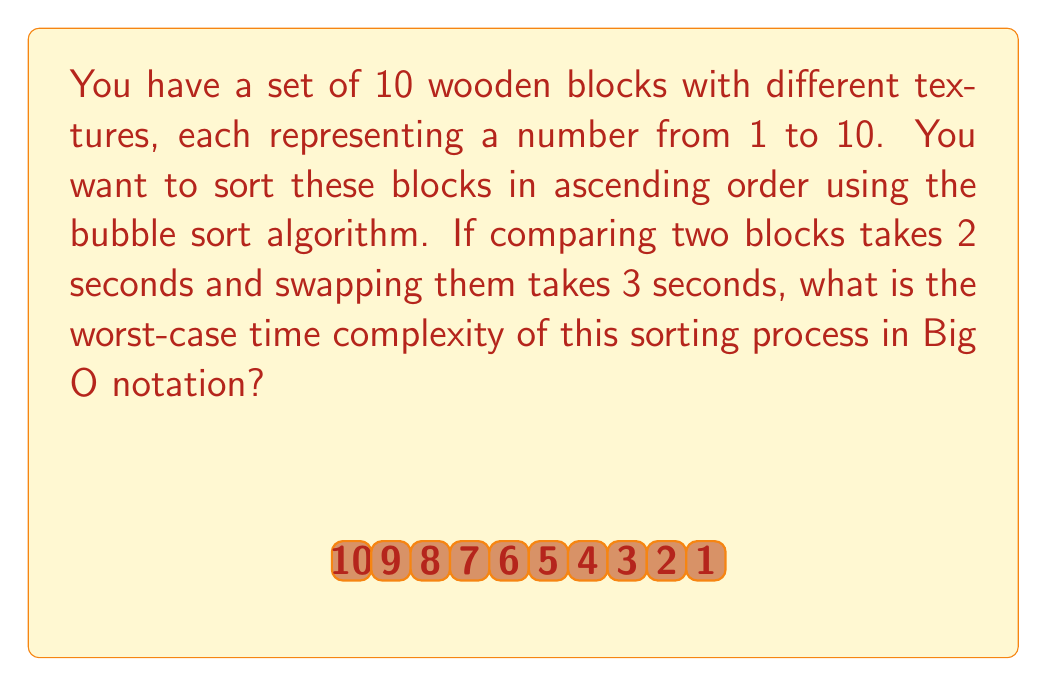What is the answer to this math problem? Let's analyze this step-by-step:

1) First, recall that bubble sort has a worst-case time complexity of $O(n^2)$, where $n$ is the number of elements to be sorted.

2) In this case, $n = 10$ (the number of wooden blocks).

3) In the worst case scenario (when the list is in reverse order), bubble sort will make:
   - $(n-1)$ comparisons in the first pass
   - $(n-2)$ comparisons in the second pass
   - ...
   - $1$ comparison in the last pass

4) The total number of comparisons is:
   $$(n-1) + (n-2) + ... + 2 + 1 = \frac{n(n-1)}{2} = \frac{10(9)}{2} = 45$$

5) Each comparison takes 2 seconds, so the total time for comparisons is:
   $$45 \times 2 = 90\text{ seconds}$$

6) In the worst case, we need to swap after each comparison. The number of swaps is the same as the number of comparisons: 45.

7) Each swap takes 3 seconds, so the total time for swaps is:
   $$45 \times 3 = 135\text{ seconds}$$

8) The total time is:
   $$90 + 135 = 225\text{ seconds}$$

9) However, the question asks for the time complexity in Big O notation. The exact time is not important for this; what matters is how the time grows with respect to the input size.

10) The number of operations (comparisons and swaps) is proportional to $n^2$, where $n$ is the number of blocks.

Therefore, the worst-case time complexity remains $O(n^2)$, regardless of the specific time taken for each operation.
Answer: $O(n^2)$ 